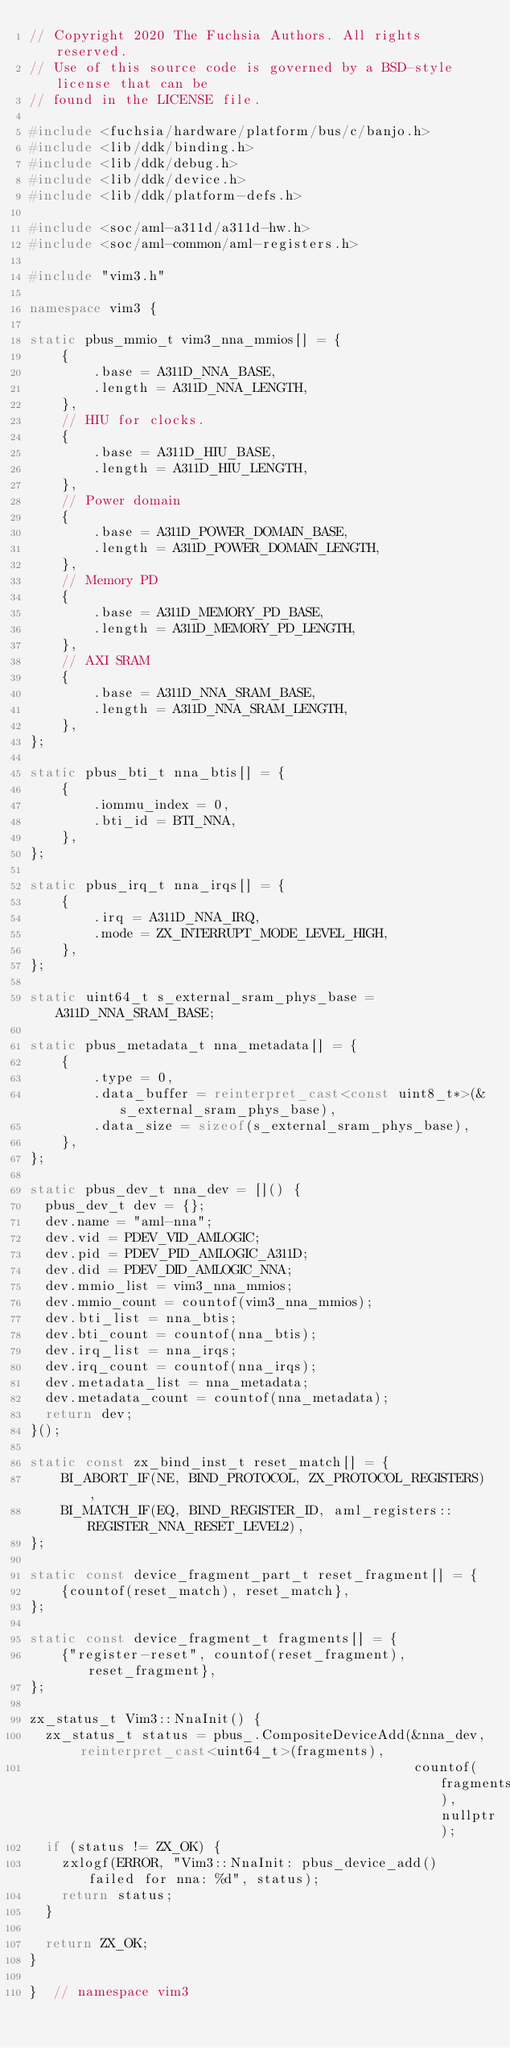Convert code to text. <code><loc_0><loc_0><loc_500><loc_500><_C++_>// Copyright 2020 The Fuchsia Authors. All rights reserved.
// Use of this source code is governed by a BSD-style license that can be
// found in the LICENSE file.

#include <fuchsia/hardware/platform/bus/c/banjo.h>
#include <lib/ddk/binding.h>
#include <lib/ddk/debug.h>
#include <lib/ddk/device.h>
#include <lib/ddk/platform-defs.h>

#include <soc/aml-a311d/a311d-hw.h>
#include <soc/aml-common/aml-registers.h>

#include "vim3.h"

namespace vim3 {

static pbus_mmio_t vim3_nna_mmios[] = {
    {
        .base = A311D_NNA_BASE,
        .length = A311D_NNA_LENGTH,
    },
    // HIU for clocks.
    {
        .base = A311D_HIU_BASE,
        .length = A311D_HIU_LENGTH,
    },
    // Power domain
    {
        .base = A311D_POWER_DOMAIN_BASE,
        .length = A311D_POWER_DOMAIN_LENGTH,
    },
    // Memory PD
    {
        .base = A311D_MEMORY_PD_BASE,
        .length = A311D_MEMORY_PD_LENGTH,
    },
    // AXI SRAM
    {
        .base = A311D_NNA_SRAM_BASE,
        .length = A311D_NNA_SRAM_LENGTH,
    },
};

static pbus_bti_t nna_btis[] = {
    {
        .iommu_index = 0,
        .bti_id = BTI_NNA,
    },
};

static pbus_irq_t nna_irqs[] = {
    {
        .irq = A311D_NNA_IRQ,
        .mode = ZX_INTERRUPT_MODE_LEVEL_HIGH,
    },
};

static uint64_t s_external_sram_phys_base = A311D_NNA_SRAM_BASE;

static pbus_metadata_t nna_metadata[] = {
    {
        .type = 0,
        .data_buffer = reinterpret_cast<const uint8_t*>(&s_external_sram_phys_base),
        .data_size = sizeof(s_external_sram_phys_base),
    },
};

static pbus_dev_t nna_dev = []() {
  pbus_dev_t dev = {};
  dev.name = "aml-nna";
  dev.vid = PDEV_VID_AMLOGIC;
  dev.pid = PDEV_PID_AMLOGIC_A311D;
  dev.did = PDEV_DID_AMLOGIC_NNA;
  dev.mmio_list = vim3_nna_mmios;
  dev.mmio_count = countof(vim3_nna_mmios);
  dev.bti_list = nna_btis;
  dev.bti_count = countof(nna_btis);
  dev.irq_list = nna_irqs;
  dev.irq_count = countof(nna_irqs);
  dev.metadata_list = nna_metadata;
  dev.metadata_count = countof(nna_metadata);
  return dev;
}();

static const zx_bind_inst_t reset_match[] = {
    BI_ABORT_IF(NE, BIND_PROTOCOL, ZX_PROTOCOL_REGISTERS),
    BI_MATCH_IF(EQ, BIND_REGISTER_ID, aml_registers::REGISTER_NNA_RESET_LEVEL2),
};

static const device_fragment_part_t reset_fragment[] = {
    {countof(reset_match), reset_match},
};

static const device_fragment_t fragments[] = {
    {"register-reset", countof(reset_fragment), reset_fragment},
};

zx_status_t Vim3::NnaInit() {
  zx_status_t status = pbus_.CompositeDeviceAdd(&nna_dev, reinterpret_cast<uint64_t>(fragments),
                                                countof(fragments), nullptr);
  if (status != ZX_OK) {
    zxlogf(ERROR, "Vim3::NnaInit: pbus_device_add() failed for nna: %d", status);
    return status;
  }

  return ZX_OK;
}

}  // namespace vim3
</code> 